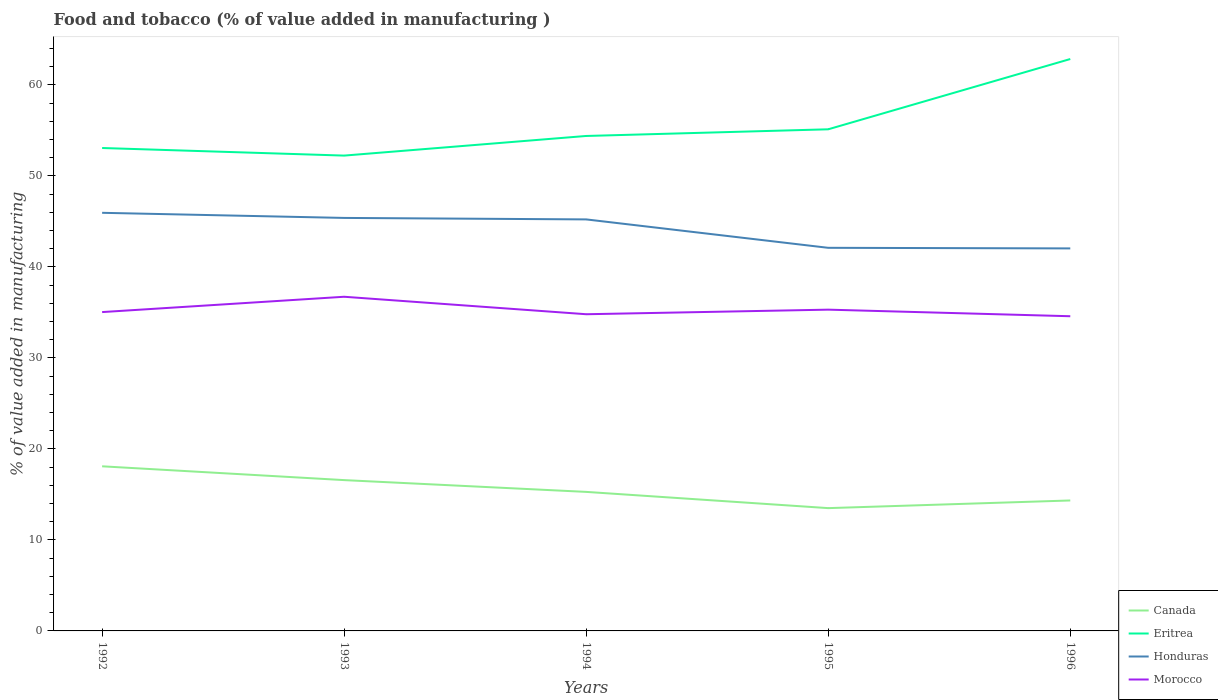How many different coloured lines are there?
Ensure brevity in your answer.  4. Across all years, what is the maximum value added in manufacturing food and tobacco in Eritrea?
Offer a very short reply. 52.22. In which year was the value added in manufacturing food and tobacco in Honduras maximum?
Keep it short and to the point. 1996. What is the total value added in manufacturing food and tobacco in Honduras in the graph?
Offer a terse response. 0.56. What is the difference between the highest and the second highest value added in manufacturing food and tobacco in Canada?
Provide a short and direct response. 4.59. What is the difference between the highest and the lowest value added in manufacturing food and tobacco in Honduras?
Provide a short and direct response. 3. How many lines are there?
Your answer should be very brief. 4. What is the difference between two consecutive major ticks on the Y-axis?
Offer a terse response. 10. Does the graph contain grids?
Provide a short and direct response. No. How many legend labels are there?
Provide a short and direct response. 4. How are the legend labels stacked?
Your response must be concise. Vertical. What is the title of the graph?
Give a very brief answer. Food and tobacco (% of value added in manufacturing ). Does "Guinea" appear as one of the legend labels in the graph?
Give a very brief answer. No. What is the label or title of the Y-axis?
Your answer should be very brief. % of value added in manufacturing. What is the % of value added in manufacturing of Canada in 1992?
Provide a short and direct response. 18.09. What is the % of value added in manufacturing of Eritrea in 1992?
Give a very brief answer. 53.06. What is the % of value added in manufacturing of Honduras in 1992?
Your response must be concise. 45.94. What is the % of value added in manufacturing in Morocco in 1992?
Offer a terse response. 35.03. What is the % of value added in manufacturing in Canada in 1993?
Provide a succinct answer. 16.57. What is the % of value added in manufacturing of Eritrea in 1993?
Provide a short and direct response. 52.22. What is the % of value added in manufacturing of Honduras in 1993?
Your answer should be very brief. 45.37. What is the % of value added in manufacturing of Morocco in 1993?
Your answer should be compact. 36.71. What is the % of value added in manufacturing of Canada in 1994?
Your response must be concise. 15.28. What is the % of value added in manufacturing of Eritrea in 1994?
Provide a short and direct response. 54.38. What is the % of value added in manufacturing in Honduras in 1994?
Your response must be concise. 45.21. What is the % of value added in manufacturing of Morocco in 1994?
Your answer should be very brief. 34.79. What is the % of value added in manufacturing in Canada in 1995?
Provide a succinct answer. 13.49. What is the % of value added in manufacturing of Eritrea in 1995?
Give a very brief answer. 55.11. What is the % of value added in manufacturing of Honduras in 1995?
Your answer should be compact. 42.09. What is the % of value added in manufacturing in Morocco in 1995?
Offer a very short reply. 35.3. What is the % of value added in manufacturing in Canada in 1996?
Make the answer very short. 14.33. What is the % of value added in manufacturing in Eritrea in 1996?
Ensure brevity in your answer.  62.83. What is the % of value added in manufacturing of Honduras in 1996?
Your answer should be very brief. 42.03. What is the % of value added in manufacturing in Morocco in 1996?
Provide a succinct answer. 34.57. Across all years, what is the maximum % of value added in manufacturing of Canada?
Give a very brief answer. 18.09. Across all years, what is the maximum % of value added in manufacturing in Eritrea?
Make the answer very short. 62.83. Across all years, what is the maximum % of value added in manufacturing of Honduras?
Your answer should be compact. 45.94. Across all years, what is the maximum % of value added in manufacturing of Morocco?
Provide a short and direct response. 36.71. Across all years, what is the minimum % of value added in manufacturing of Canada?
Provide a succinct answer. 13.49. Across all years, what is the minimum % of value added in manufacturing of Eritrea?
Ensure brevity in your answer.  52.22. Across all years, what is the minimum % of value added in manufacturing in Honduras?
Ensure brevity in your answer.  42.03. Across all years, what is the minimum % of value added in manufacturing of Morocco?
Make the answer very short. 34.57. What is the total % of value added in manufacturing in Canada in the graph?
Offer a terse response. 77.75. What is the total % of value added in manufacturing in Eritrea in the graph?
Make the answer very short. 277.61. What is the total % of value added in manufacturing in Honduras in the graph?
Provide a short and direct response. 220.64. What is the total % of value added in manufacturing of Morocco in the graph?
Offer a terse response. 176.41. What is the difference between the % of value added in manufacturing of Canada in 1992 and that in 1993?
Your response must be concise. 1.52. What is the difference between the % of value added in manufacturing of Eritrea in 1992 and that in 1993?
Offer a very short reply. 0.83. What is the difference between the % of value added in manufacturing in Honduras in 1992 and that in 1993?
Your answer should be very brief. 0.56. What is the difference between the % of value added in manufacturing in Morocco in 1992 and that in 1993?
Ensure brevity in your answer.  -1.68. What is the difference between the % of value added in manufacturing in Canada in 1992 and that in 1994?
Offer a very short reply. 2.81. What is the difference between the % of value added in manufacturing in Eritrea in 1992 and that in 1994?
Make the answer very short. -1.32. What is the difference between the % of value added in manufacturing of Honduras in 1992 and that in 1994?
Ensure brevity in your answer.  0.73. What is the difference between the % of value added in manufacturing in Morocco in 1992 and that in 1994?
Offer a very short reply. 0.24. What is the difference between the % of value added in manufacturing in Canada in 1992 and that in 1995?
Provide a short and direct response. 4.59. What is the difference between the % of value added in manufacturing in Eritrea in 1992 and that in 1995?
Your response must be concise. -2.06. What is the difference between the % of value added in manufacturing in Honduras in 1992 and that in 1995?
Ensure brevity in your answer.  3.85. What is the difference between the % of value added in manufacturing in Morocco in 1992 and that in 1995?
Provide a succinct answer. -0.27. What is the difference between the % of value added in manufacturing of Canada in 1992 and that in 1996?
Provide a short and direct response. 3.75. What is the difference between the % of value added in manufacturing of Eritrea in 1992 and that in 1996?
Your response must be concise. -9.77. What is the difference between the % of value added in manufacturing in Honduras in 1992 and that in 1996?
Ensure brevity in your answer.  3.91. What is the difference between the % of value added in manufacturing of Morocco in 1992 and that in 1996?
Provide a short and direct response. 0.46. What is the difference between the % of value added in manufacturing in Canada in 1993 and that in 1994?
Make the answer very short. 1.29. What is the difference between the % of value added in manufacturing in Eritrea in 1993 and that in 1994?
Make the answer very short. -2.16. What is the difference between the % of value added in manufacturing of Honduras in 1993 and that in 1994?
Offer a terse response. 0.16. What is the difference between the % of value added in manufacturing in Morocco in 1993 and that in 1994?
Give a very brief answer. 1.92. What is the difference between the % of value added in manufacturing in Canada in 1993 and that in 1995?
Keep it short and to the point. 3.08. What is the difference between the % of value added in manufacturing in Eritrea in 1993 and that in 1995?
Provide a succinct answer. -2.89. What is the difference between the % of value added in manufacturing of Honduras in 1993 and that in 1995?
Your answer should be compact. 3.28. What is the difference between the % of value added in manufacturing of Morocco in 1993 and that in 1995?
Offer a very short reply. 1.42. What is the difference between the % of value added in manufacturing in Canada in 1993 and that in 1996?
Your answer should be very brief. 2.24. What is the difference between the % of value added in manufacturing in Eritrea in 1993 and that in 1996?
Offer a terse response. -10.61. What is the difference between the % of value added in manufacturing in Honduras in 1993 and that in 1996?
Offer a very short reply. 3.35. What is the difference between the % of value added in manufacturing in Morocco in 1993 and that in 1996?
Give a very brief answer. 2.14. What is the difference between the % of value added in manufacturing of Canada in 1994 and that in 1995?
Your answer should be compact. 1.78. What is the difference between the % of value added in manufacturing of Eritrea in 1994 and that in 1995?
Make the answer very short. -0.73. What is the difference between the % of value added in manufacturing in Honduras in 1994 and that in 1995?
Provide a short and direct response. 3.12. What is the difference between the % of value added in manufacturing of Morocco in 1994 and that in 1995?
Your response must be concise. -0.5. What is the difference between the % of value added in manufacturing of Canada in 1994 and that in 1996?
Your answer should be very brief. 0.94. What is the difference between the % of value added in manufacturing in Eritrea in 1994 and that in 1996?
Give a very brief answer. -8.45. What is the difference between the % of value added in manufacturing of Honduras in 1994 and that in 1996?
Offer a very short reply. 3.19. What is the difference between the % of value added in manufacturing of Morocco in 1994 and that in 1996?
Ensure brevity in your answer.  0.22. What is the difference between the % of value added in manufacturing of Canada in 1995 and that in 1996?
Keep it short and to the point. -0.84. What is the difference between the % of value added in manufacturing in Eritrea in 1995 and that in 1996?
Provide a short and direct response. -7.72. What is the difference between the % of value added in manufacturing in Honduras in 1995 and that in 1996?
Your answer should be very brief. 0.07. What is the difference between the % of value added in manufacturing in Morocco in 1995 and that in 1996?
Your response must be concise. 0.72. What is the difference between the % of value added in manufacturing in Canada in 1992 and the % of value added in manufacturing in Eritrea in 1993?
Provide a short and direct response. -34.14. What is the difference between the % of value added in manufacturing of Canada in 1992 and the % of value added in manufacturing of Honduras in 1993?
Ensure brevity in your answer.  -27.29. What is the difference between the % of value added in manufacturing of Canada in 1992 and the % of value added in manufacturing of Morocco in 1993?
Provide a short and direct response. -18.63. What is the difference between the % of value added in manufacturing in Eritrea in 1992 and the % of value added in manufacturing in Honduras in 1993?
Provide a short and direct response. 7.68. What is the difference between the % of value added in manufacturing of Eritrea in 1992 and the % of value added in manufacturing of Morocco in 1993?
Make the answer very short. 16.34. What is the difference between the % of value added in manufacturing in Honduras in 1992 and the % of value added in manufacturing in Morocco in 1993?
Keep it short and to the point. 9.22. What is the difference between the % of value added in manufacturing of Canada in 1992 and the % of value added in manufacturing of Eritrea in 1994?
Your answer should be very brief. -36.29. What is the difference between the % of value added in manufacturing of Canada in 1992 and the % of value added in manufacturing of Honduras in 1994?
Keep it short and to the point. -27.13. What is the difference between the % of value added in manufacturing of Canada in 1992 and the % of value added in manufacturing of Morocco in 1994?
Offer a terse response. -16.71. What is the difference between the % of value added in manufacturing of Eritrea in 1992 and the % of value added in manufacturing of Honduras in 1994?
Give a very brief answer. 7.85. What is the difference between the % of value added in manufacturing of Eritrea in 1992 and the % of value added in manufacturing of Morocco in 1994?
Keep it short and to the point. 18.26. What is the difference between the % of value added in manufacturing in Honduras in 1992 and the % of value added in manufacturing in Morocco in 1994?
Offer a very short reply. 11.14. What is the difference between the % of value added in manufacturing in Canada in 1992 and the % of value added in manufacturing in Eritrea in 1995?
Offer a terse response. -37.03. What is the difference between the % of value added in manufacturing in Canada in 1992 and the % of value added in manufacturing in Honduras in 1995?
Provide a succinct answer. -24. What is the difference between the % of value added in manufacturing of Canada in 1992 and the % of value added in manufacturing of Morocco in 1995?
Ensure brevity in your answer.  -17.21. What is the difference between the % of value added in manufacturing in Eritrea in 1992 and the % of value added in manufacturing in Honduras in 1995?
Provide a succinct answer. 10.97. What is the difference between the % of value added in manufacturing of Eritrea in 1992 and the % of value added in manufacturing of Morocco in 1995?
Keep it short and to the point. 17.76. What is the difference between the % of value added in manufacturing in Honduras in 1992 and the % of value added in manufacturing in Morocco in 1995?
Your response must be concise. 10.64. What is the difference between the % of value added in manufacturing of Canada in 1992 and the % of value added in manufacturing of Eritrea in 1996?
Offer a terse response. -44.75. What is the difference between the % of value added in manufacturing of Canada in 1992 and the % of value added in manufacturing of Honduras in 1996?
Provide a succinct answer. -23.94. What is the difference between the % of value added in manufacturing of Canada in 1992 and the % of value added in manufacturing of Morocco in 1996?
Make the answer very short. -16.49. What is the difference between the % of value added in manufacturing in Eritrea in 1992 and the % of value added in manufacturing in Honduras in 1996?
Give a very brief answer. 11.03. What is the difference between the % of value added in manufacturing of Eritrea in 1992 and the % of value added in manufacturing of Morocco in 1996?
Provide a short and direct response. 18.48. What is the difference between the % of value added in manufacturing of Honduras in 1992 and the % of value added in manufacturing of Morocco in 1996?
Ensure brevity in your answer.  11.36. What is the difference between the % of value added in manufacturing of Canada in 1993 and the % of value added in manufacturing of Eritrea in 1994?
Provide a succinct answer. -37.81. What is the difference between the % of value added in manufacturing in Canada in 1993 and the % of value added in manufacturing in Honduras in 1994?
Your response must be concise. -28.64. What is the difference between the % of value added in manufacturing of Canada in 1993 and the % of value added in manufacturing of Morocco in 1994?
Your response must be concise. -18.22. What is the difference between the % of value added in manufacturing of Eritrea in 1993 and the % of value added in manufacturing of Honduras in 1994?
Keep it short and to the point. 7.01. What is the difference between the % of value added in manufacturing of Eritrea in 1993 and the % of value added in manufacturing of Morocco in 1994?
Ensure brevity in your answer.  17.43. What is the difference between the % of value added in manufacturing of Honduras in 1993 and the % of value added in manufacturing of Morocco in 1994?
Provide a succinct answer. 10.58. What is the difference between the % of value added in manufacturing in Canada in 1993 and the % of value added in manufacturing in Eritrea in 1995?
Offer a terse response. -38.54. What is the difference between the % of value added in manufacturing of Canada in 1993 and the % of value added in manufacturing of Honduras in 1995?
Offer a very short reply. -25.52. What is the difference between the % of value added in manufacturing of Canada in 1993 and the % of value added in manufacturing of Morocco in 1995?
Your answer should be very brief. -18.73. What is the difference between the % of value added in manufacturing of Eritrea in 1993 and the % of value added in manufacturing of Honduras in 1995?
Keep it short and to the point. 10.13. What is the difference between the % of value added in manufacturing of Eritrea in 1993 and the % of value added in manufacturing of Morocco in 1995?
Make the answer very short. 16.93. What is the difference between the % of value added in manufacturing in Honduras in 1993 and the % of value added in manufacturing in Morocco in 1995?
Your response must be concise. 10.08. What is the difference between the % of value added in manufacturing of Canada in 1993 and the % of value added in manufacturing of Eritrea in 1996?
Offer a very short reply. -46.26. What is the difference between the % of value added in manufacturing in Canada in 1993 and the % of value added in manufacturing in Honduras in 1996?
Provide a short and direct response. -25.46. What is the difference between the % of value added in manufacturing in Canada in 1993 and the % of value added in manufacturing in Morocco in 1996?
Offer a terse response. -18. What is the difference between the % of value added in manufacturing of Eritrea in 1993 and the % of value added in manufacturing of Honduras in 1996?
Your answer should be compact. 10.2. What is the difference between the % of value added in manufacturing in Eritrea in 1993 and the % of value added in manufacturing in Morocco in 1996?
Provide a short and direct response. 17.65. What is the difference between the % of value added in manufacturing of Honduras in 1993 and the % of value added in manufacturing of Morocco in 1996?
Your response must be concise. 10.8. What is the difference between the % of value added in manufacturing in Canada in 1994 and the % of value added in manufacturing in Eritrea in 1995?
Offer a very short reply. -39.84. What is the difference between the % of value added in manufacturing of Canada in 1994 and the % of value added in manufacturing of Honduras in 1995?
Keep it short and to the point. -26.82. What is the difference between the % of value added in manufacturing in Canada in 1994 and the % of value added in manufacturing in Morocco in 1995?
Your response must be concise. -20.02. What is the difference between the % of value added in manufacturing in Eritrea in 1994 and the % of value added in manufacturing in Honduras in 1995?
Ensure brevity in your answer.  12.29. What is the difference between the % of value added in manufacturing of Eritrea in 1994 and the % of value added in manufacturing of Morocco in 1995?
Your answer should be very brief. 19.08. What is the difference between the % of value added in manufacturing of Honduras in 1994 and the % of value added in manufacturing of Morocco in 1995?
Offer a very short reply. 9.91. What is the difference between the % of value added in manufacturing in Canada in 1994 and the % of value added in manufacturing in Eritrea in 1996?
Offer a terse response. -47.56. What is the difference between the % of value added in manufacturing of Canada in 1994 and the % of value added in manufacturing of Honduras in 1996?
Ensure brevity in your answer.  -26.75. What is the difference between the % of value added in manufacturing in Canada in 1994 and the % of value added in manufacturing in Morocco in 1996?
Keep it short and to the point. -19.3. What is the difference between the % of value added in manufacturing of Eritrea in 1994 and the % of value added in manufacturing of Honduras in 1996?
Ensure brevity in your answer.  12.35. What is the difference between the % of value added in manufacturing of Eritrea in 1994 and the % of value added in manufacturing of Morocco in 1996?
Your answer should be compact. 19.81. What is the difference between the % of value added in manufacturing of Honduras in 1994 and the % of value added in manufacturing of Morocco in 1996?
Offer a terse response. 10.64. What is the difference between the % of value added in manufacturing in Canada in 1995 and the % of value added in manufacturing in Eritrea in 1996?
Your answer should be compact. -49.34. What is the difference between the % of value added in manufacturing of Canada in 1995 and the % of value added in manufacturing of Honduras in 1996?
Make the answer very short. -28.53. What is the difference between the % of value added in manufacturing of Canada in 1995 and the % of value added in manufacturing of Morocco in 1996?
Your answer should be compact. -21.08. What is the difference between the % of value added in manufacturing in Eritrea in 1995 and the % of value added in manufacturing in Honduras in 1996?
Your answer should be compact. 13.09. What is the difference between the % of value added in manufacturing of Eritrea in 1995 and the % of value added in manufacturing of Morocco in 1996?
Ensure brevity in your answer.  20.54. What is the difference between the % of value added in manufacturing in Honduras in 1995 and the % of value added in manufacturing in Morocco in 1996?
Your answer should be very brief. 7.52. What is the average % of value added in manufacturing in Canada per year?
Ensure brevity in your answer.  15.55. What is the average % of value added in manufacturing of Eritrea per year?
Offer a terse response. 55.52. What is the average % of value added in manufacturing in Honduras per year?
Make the answer very short. 44.13. What is the average % of value added in manufacturing of Morocco per year?
Offer a very short reply. 35.28. In the year 1992, what is the difference between the % of value added in manufacturing of Canada and % of value added in manufacturing of Eritrea?
Make the answer very short. -34.97. In the year 1992, what is the difference between the % of value added in manufacturing in Canada and % of value added in manufacturing in Honduras?
Make the answer very short. -27.85. In the year 1992, what is the difference between the % of value added in manufacturing in Canada and % of value added in manufacturing in Morocco?
Ensure brevity in your answer.  -16.94. In the year 1992, what is the difference between the % of value added in manufacturing in Eritrea and % of value added in manufacturing in Honduras?
Offer a terse response. 7.12. In the year 1992, what is the difference between the % of value added in manufacturing in Eritrea and % of value added in manufacturing in Morocco?
Offer a very short reply. 18.03. In the year 1992, what is the difference between the % of value added in manufacturing in Honduras and % of value added in manufacturing in Morocco?
Offer a very short reply. 10.91. In the year 1993, what is the difference between the % of value added in manufacturing of Canada and % of value added in manufacturing of Eritrea?
Make the answer very short. -35.65. In the year 1993, what is the difference between the % of value added in manufacturing of Canada and % of value added in manufacturing of Honduras?
Make the answer very short. -28.81. In the year 1993, what is the difference between the % of value added in manufacturing of Canada and % of value added in manufacturing of Morocco?
Give a very brief answer. -20.14. In the year 1993, what is the difference between the % of value added in manufacturing in Eritrea and % of value added in manufacturing in Honduras?
Provide a short and direct response. 6.85. In the year 1993, what is the difference between the % of value added in manufacturing of Eritrea and % of value added in manufacturing of Morocco?
Your answer should be very brief. 15.51. In the year 1993, what is the difference between the % of value added in manufacturing in Honduras and % of value added in manufacturing in Morocco?
Keep it short and to the point. 8.66. In the year 1994, what is the difference between the % of value added in manufacturing of Canada and % of value added in manufacturing of Eritrea?
Keep it short and to the point. -39.1. In the year 1994, what is the difference between the % of value added in manufacturing of Canada and % of value added in manufacturing of Honduras?
Offer a terse response. -29.94. In the year 1994, what is the difference between the % of value added in manufacturing in Canada and % of value added in manufacturing in Morocco?
Your answer should be very brief. -19.52. In the year 1994, what is the difference between the % of value added in manufacturing of Eritrea and % of value added in manufacturing of Honduras?
Your answer should be compact. 9.17. In the year 1994, what is the difference between the % of value added in manufacturing of Eritrea and % of value added in manufacturing of Morocco?
Your answer should be compact. 19.59. In the year 1994, what is the difference between the % of value added in manufacturing of Honduras and % of value added in manufacturing of Morocco?
Offer a terse response. 10.42. In the year 1995, what is the difference between the % of value added in manufacturing of Canada and % of value added in manufacturing of Eritrea?
Your answer should be very brief. -41.62. In the year 1995, what is the difference between the % of value added in manufacturing in Canada and % of value added in manufacturing in Honduras?
Offer a very short reply. -28.6. In the year 1995, what is the difference between the % of value added in manufacturing in Canada and % of value added in manufacturing in Morocco?
Provide a short and direct response. -21.81. In the year 1995, what is the difference between the % of value added in manufacturing in Eritrea and % of value added in manufacturing in Honduras?
Ensure brevity in your answer.  13.02. In the year 1995, what is the difference between the % of value added in manufacturing in Eritrea and % of value added in manufacturing in Morocco?
Your answer should be very brief. 19.82. In the year 1995, what is the difference between the % of value added in manufacturing of Honduras and % of value added in manufacturing of Morocco?
Your answer should be very brief. 6.79. In the year 1996, what is the difference between the % of value added in manufacturing of Canada and % of value added in manufacturing of Eritrea?
Provide a succinct answer. -48.5. In the year 1996, what is the difference between the % of value added in manufacturing in Canada and % of value added in manufacturing in Honduras?
Offer a very short reply. -27.69. In the year 1996, what is the difference between the % of value added in manufacturing of Canada and % of value added in manufacturing of Morocco?
Provide a succinct answer. -20.24. In the year 1996, what is the difference between the % of value added in manufacturing of Eritrea and % of value added in manufacturing of Honduras?
Provide a short and direct response. 20.81. In the year 1996, what is the difference between the % of value added in manufacturing in Eritrea and % of value added in manufacturing in Morocco?
Make the answer very short. 28.26. In the year 1996, what is the difference between the % of value added in manufacturing of Honduras and % of value added in manufacturing of Morocco?
Keep it short and to the point. 7.45. What is the ratio of the % of value added in manufacturing in Canada in 1992 to that in 1993?
Keep it short and to the point. 1.09. What is the ratio of the % of value added in manufacturing in Honduras in 1992 to that in 1993?
Provide a succinct answer. 1.01. What is the ratio of the % of value added in manufacturing in Morocco in 1992 to that in 1993?
Provide a succinct answer. 0.95. What is the ratio of the % of value added in manufacturing in Canada in 1992 to that in 1994?
Your answer should be compact. 1.18. What is the ratio of the % of value added in manufacturing of Eritrea in 1992 to that in 1994?
Your answer should be very brief. 0.98. What is the ratio of the % of value added in manufacturing of Honduras in 1992 to that in 1994?
Your response must be concise. 1.02. What is the ratio of the % of value added in manufacturing of Morocco in 1992 to that in 1994?
Your response must be concise. 1.01. What is the ratio of the % of value added in manufacturing in Canada in 1992 to that in 1995?
Give a very brief answer. 1.34. What is the ratio of the % of value added in manufacturing in Eritrea in 1992 to that in 1995?
Your answer should be very brief. 0.96. What is the ratio of the % of value added in manufacturing of Honduras in 1992 to that in 1995?
Offer a terse response. 1.09. What is the ratio of the % of value added in manufacturing of Canada in 1992 to that in 1996?
Offer a very short reply. 1.26. What is the ratio of the % of value added in manufacturing in Eritrea in 1992 to that in 1996?
Make the answer very short. 0.84. What is the ratio of the % of value added in manufacturing in Honduras in 1992 to that in 1996?
Offer a terse response. 1.09. What is the ratio of the % of value added in manufacturing of Morocco in 1992 to that in 1996?
Keep it short and to the point. 1.01. What is the ratio of the % of value added in manufacturing of Canada in 1993 to that in 1994?
Provide a short and direct response. 1.08. What is the ratio of the % of value added in manufacturing of Eritrea in 1993 to that in 1994?
Provide a short and direct response. 0.96. What is the ratio of the % of value added in manufacturing in Honduras in 1993 to that in 1994?
Your answer should be compact. 1. What is the ratio of the % of value added in manufacturing in Morocco in 1993 to that in 1994?
Keep it short and to the point. 1.06. What is the ratio of the % of value added in manufacturing in Canada in 1993 to that in 1995?
Keep it short and to the point. 1.23. What is the ratio of the % of value added in manufacturing in Eritrea in 1993 to that in 1995?
Keep it short and to the point. 0.95. What is the ratio of the % of value added in manufacturing of Honduras in 1993 to that in 1995?
Your answer should be compact. 1.08. What is the ratio of the % of value added in manufacturing in Morocco in 1993 to that in 1995?
Keep it short and to the point. 1.04. What is the ratio of the % of value added in manufacturing of Canada in 1993 to that in 1996?
Provide a short and direct response. 1.16. What is the ratio of the % of value added in manufacturing in Eritrea in 1993 to that in 1996?
Provide a succinct answer. 0.83. What is the ratio of the % of value added in manufacturing of Honduras in 1993 to that in 1996?
Provide a succinct answer. 1.08. What is the ratio of the % of value added in manufacturing of Morocco in 1993 to that in 1996?
Ensure brevity in your answer.  1.06. What is the ratio of the % of value added in manufacturing of Canada in 1994 to that in 1995?
Provide a short and direct response. 1.13. What is the ratio of the % of value added in manufacturing of Eritrea in 1994 to that in 1995?
Offer a terse response. 0.99. What is the ratio of the % of value added in manufacturing in Honduras in 1994 to that in 1995?
Your answer should be compact. 1.07. What is the ratio of the % of value added in manufacturing in Morocco in 1994 to that in 1995?
Provide a succinct answer. 0.99. What is the ratio of the % of value added in manufacturing in Canada in 1994 to that in 1996?
Offer a terse response. 1.07. What is the ratio of the % of value added in manufacturing of Eritrea in 1994 to that in 1996?
Give a very brief answer. 0.87. What is the ratio of the % of value added in manufacturing of Honduras in 1994 to that in 1996?
Provide a short and direct response. 1.08. What is the ratio of the % of value added in manufacturing of Morocco in 1994 to that in 1996?
Provide a succinct answer. 1.01. What is the ratio of the % of value added in manufacturing in Canada in 1995 to that in 1996?
Ensure brevity in your answer.  0.94. What is the ratio of the % of value added in manufacturing in Eritrea in 1995 to that in 1996?
Your answer should be very brief. 0.88. What is the ratio of the % of value added in manufacturing in Morocco in 1995 to that in 1996?
Provide a succinct answer. 1.02. What is the difference between the highest and the second highest % of value added in manufacturing of Canada?
Your response must be concise. 1.52. What is the difference between the highest and the second highest % of value added in manufacturing of Eritrea?
Your response must be concise. 7.72. What is the difference between the highest and the second highest % of value added in manufacturing of Honduras?
Give a very brief answer. 0.56. What is the difference between the highest and the second highest % of value added in manufacturing of Morocco?
Ensure brevity in your answer.  1.42. What is the difference between the highest and the lowest % of value added in manufacturing in Canada?
Provide a succinct answer. 4.59. What is the difference between the highest and the lowest % of value added in manufacturing of Eritrea?
Your answer should be compact. 10.61. What is the difference between the highest and the lowest % of value added in manufacturing in Honduras?
Your response must be concise. 3.91. What is the difference between the highest and the lowest % of value added in manufacturing in Morocco?
Offer a very short reply. 2.14. 